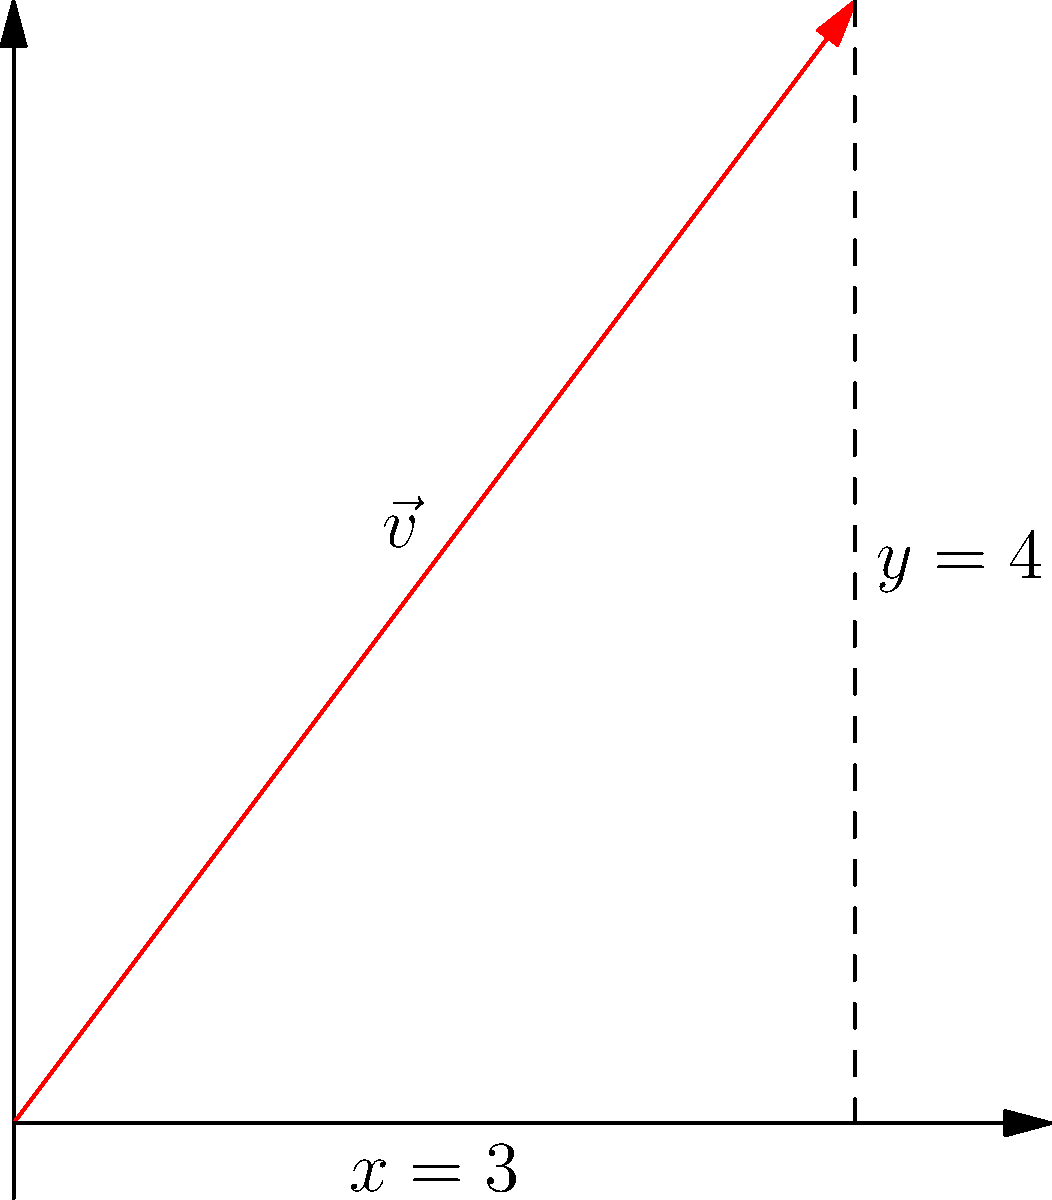As a college student using software for your coursework, you encounter a vector problem. Given a vector $\vec{v}$ with components $x = 3$ and $y = 4$, calculate its magnitude and direction (in degrees, rounded to the nearest whole number). Express the direction as the counterclockwise angle from the positive x-axis. To solve this problem, we'll follow these steps:

1. Calculate the magnitude:
   The magnitude of a vector is given by the Pythagorean theorem:
   $$|\vec{v}| = \sqrt{x^2 + y^2}$$
   $$|\vec{v}| = \sqrt{3^2 + 4^2} = \sqrt{9 + 16} = \sqrt{25} = 5$$

2. Calculate the direction:
   The direction is given by the arctangent of y/x:
   $$\theta = \tan^{-1}\left(\frac{y}{x}\right)$$
   $$\theta = \tan^{-1}\left(\frac{4}{3}\right) \approx 53.13^\circ$$

3. Round the angle to the nearest whole number:
   $53.13^\circ$ rounded to the nearest whole number is $53^\circ$.

Therefore, the magnitude of the vector is 5 units, and its direction is 53° counterclockwise from the positive x-axis.
Answer: Magnitude: 5, Direction: 53° 